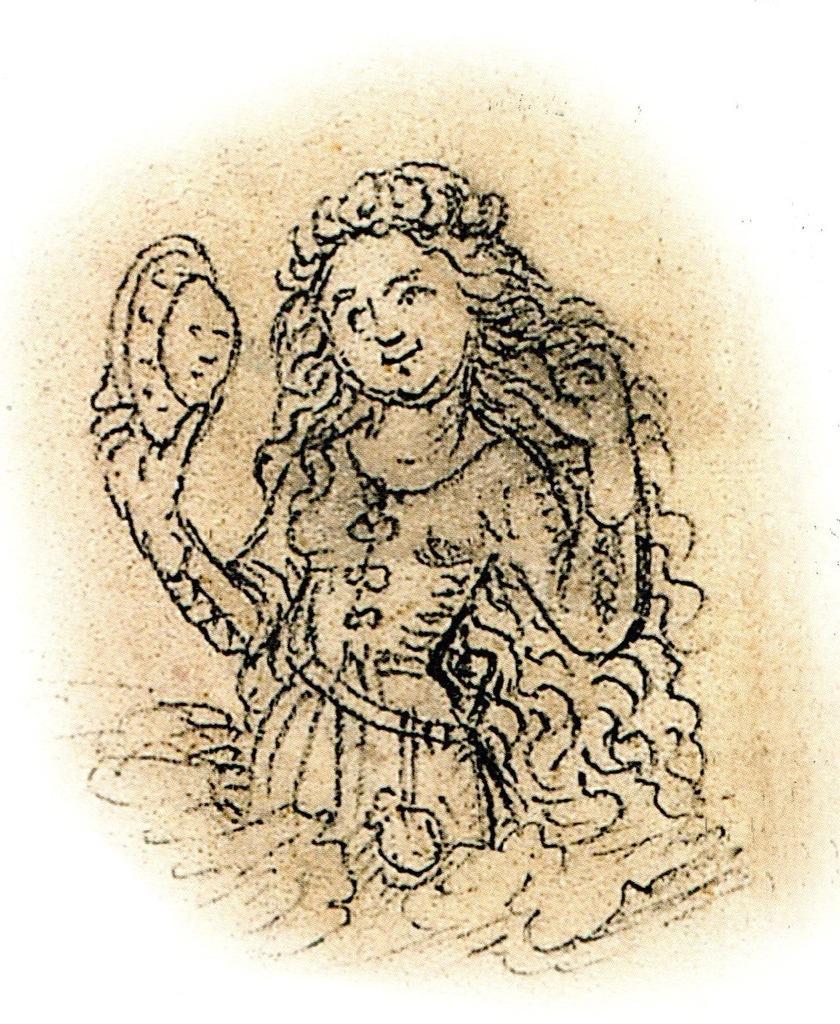Could you give a brief overview of what you see in this image? In this image there is a picture of a girl holding the object. 